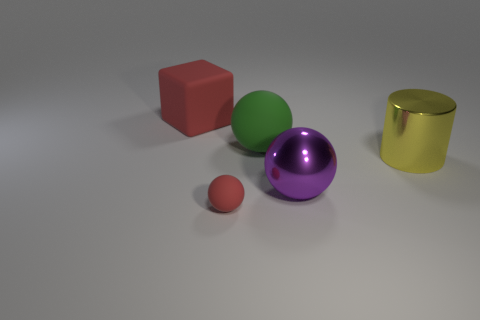What is the size of the metallic cylinder that is right of the rubber object behind the green matte ball that is right of the big red matte object?
Your answer should be compact. Large. The large matte cube has what color?
Keep it short and to the point. Red. Are there more large green things that are left of the large purple ball than tiny yellow shiny spheres?
Ensure brevity in your answer.  Yes. There is a yellow metallic cylinder; what number of tiny red matte objects are behind it?
Provide a succinct answer. 0. The small matte thing that is the same color as the big matte block is what shape?
Keep it short and to the point. Sphere. Are there any spheres to the right of the matte ball behind the red thing that is in front of the matte cube?
Ensure brevity in your answer.  Yes. Do the matte block and the metal ball have the same size?
Provide a succinct answer. Yes. Is the number of green spheres that are in front of the big cylinder the same as the number of big purple spheres that are to the right of the large red cube?
Ensure brevity in your answer.  No. There is a big metallic object that is right of the big purple shiny object; what shape is it?
Provide a succinct answer. Cylinder. What is the shape of the red object that is the same size as the yellow cylinder?
Ensure brevity in your answer.  Cube. 